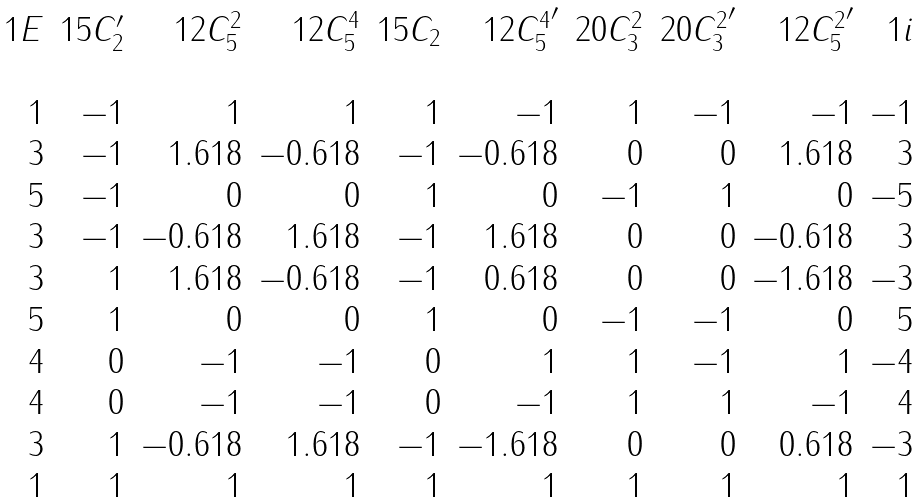<formula> <loc_0><loc_0><loc_500><loc_500>\begin{array} { r r r r r r r r r r } 1 E & 1 5 { C _ { 2 } ^ { \prime } } & 1 2 { C _ { 5 } ^ { 2 } } & 1 2 { C _ { 5 } ^ { 4 } } & 1 5 { C _ { 2 } } & 1 2 { { C _ { 5 } ^ { 4 } } ^ { \prime } } & 2 0 { C _ { 3 } ^ { 2 } } & 2 0 { { C _ { 3 } ^ { 2 } } ^ { \prime } } & 1 2 { { C _ { 5 } ^ { 2 } } ^ { \prime } } & 1 i \\ \\ 1 & - 1 & 1 & 1 & 1 & - 1 & 1 & - 1 & - 1 & - 1 \\ 3 & - 1 & 1 . 6 1 8 & - 0 . 6 1 8 & - 1 & - 0 . 6 1 8 & 0 & 0 & 1 . 6 1 8 & 3 \\ 5 & - 1 & 0 & 0 & 1 & 0 & - 1 & 1 & 0 & - 5 \\ 3 & - 1 & - 0 . 6 1 8 & 1 . 6 1 8 & - 1 & 1 . 6 1 8 & 0 & 0 & - 0 . 6 1 8 & 3 \\ 3 & 1 & 1 . 6 1 8 & - 0 . 6 1 8 & - 1 & 0 . 6 1 8 & 0 & 0 & - 1 . 6 1 8 & - 3 \\ 5 & 1 & 0 & 0 & 1 & 0 & - 1 & - 1 & 0 & 5 \\ 4 & 0 & - 1 & - 1 & 0 & 1 & 1 & - 1 & 1 & - 4 \\ 4 & 0 & - 1 & - 1 & 0 & - 1 & 1 & 1 & - 1 & 4 \\ 3 & 1 & - 0 . 6 1 8 & 1 . 6 1 8 & - 1 & - 1 . 6 1 8 & 0 & 0 & 0 . 6 1 8 & - 3 \\ 1 & 1 & 1 & 1 & 1 & 1 & 1 & 1 & 1 & 1 \end{array}</formula> 